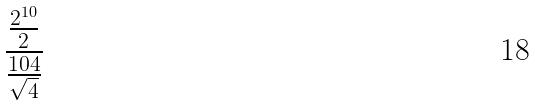<formula> <loc_0><loc_0><loc_500><loc_500>\frac { \frac { 2 ^ { 1 0 } } { 2 } } { \frac { 1 0 4 } { \sqrt { 4 } } }</formula> 